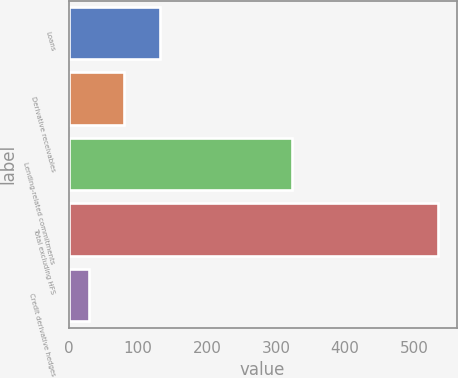Convert chart to OTSL. <chart><loc_0><loc_0><loc_500><loc_500><bar_chart><fcel>Loans<fcel>Derivative receivables<fcel>Lending-related commitments<fcel>Total excluding HFS<fcel>Credit derivative hedges<nl><fcel>132<fcel>80.5<fcel>324<fcel>535<fcel>30<nl></chart> 